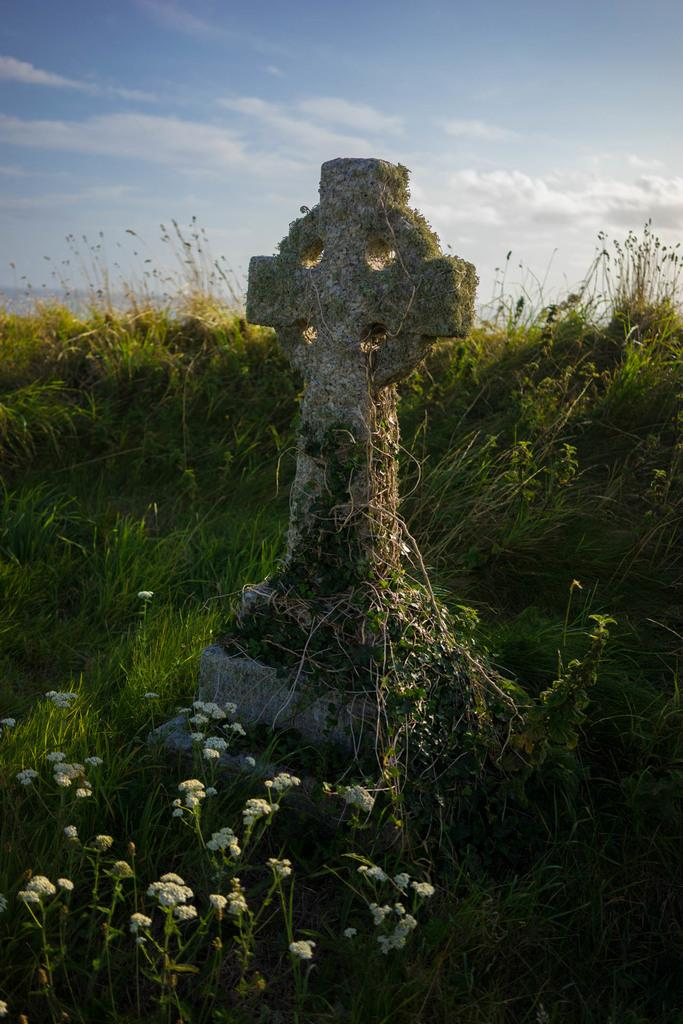What type of natural formation is present in the image? There is a rock structure in the image. What type of vegetation is present around the rock structure? There is grass and plants around the rock structure. What can be seen in the background of the image? The sky is visible in the background of the image. What type of neck accessory is visible on the rock structure in the image? There is no neck accessory present on the rock structure in the image. What type of birds can be seen flying around the rock structure in the image? There are no birds visible in the image. 